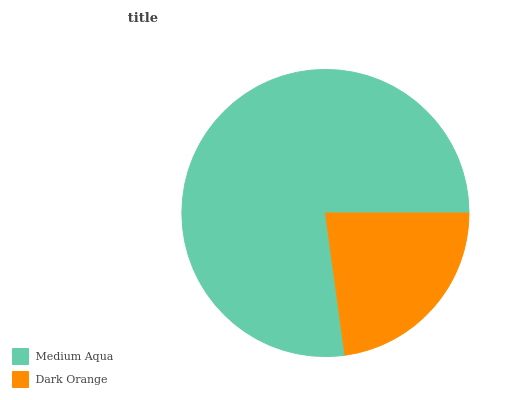Is Dark Orange the minimum?
Answer yes or no. Yes. Is Medium Aqua the maximum?
Answer yes or no. Yes. Is Dark Orange the maximum?
Answer yes or no. No. Is Medium Aqua greater than Dark Orange?
Answer yes or no. Yes. Is Dark Orange less than Medium Aqua?
Answer yes or no. Yes. Is Dark Orange greater than Medium Aqua?
Answer yes or no. No. Is Medium Aqua less than Dark Orange?
Answer yes or no. No. Is Medium Aqua the high median?
Answer yes or no. Yes. Is Dark Orange the low median?
Answer yes or no. Yes. Is Dark Orange the high median?
Answer yes or no. No. Is Medium Aqua the low median?
Answer yes or no. No. 